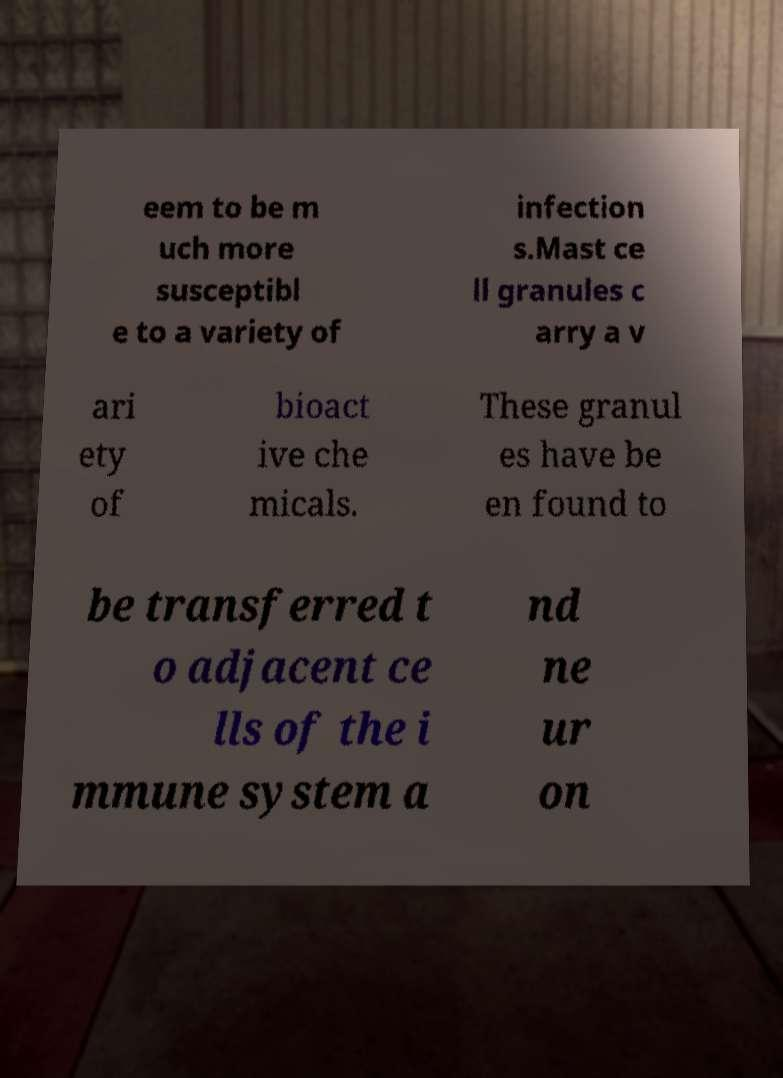Can you accurately transcribe the text from the provided image for me? eem to be m uch more susceptibl e to a variety of infection s.Mast ce ll granules c arry a v ari ety of bioact ive che micals. These granul es have be en found to be transferred t o adjacent ce lls of the i mmune system a nd ne ur on 